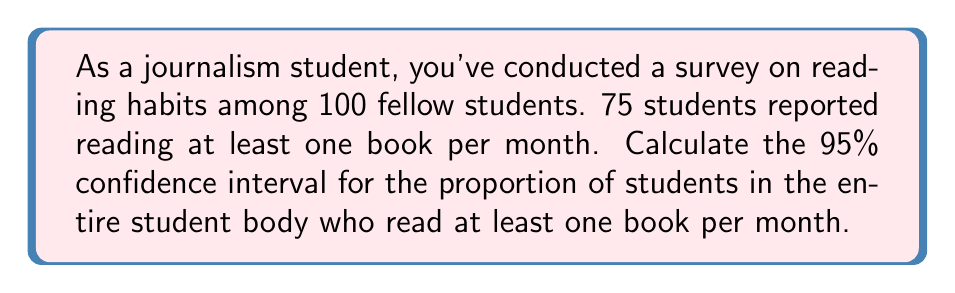Give your solution to this math problem. Let's approach this step-by-step:

1) We're dealing with a proportion, so we'll use the formula for the confidence interval of a proportion:

   $$p \pm z\sqrt{\frac{p(1-p)}{n}}$$

   Where:
   $p$ = sample proportion
   $z$ = z-score for desired confidence level
   $n$ = sample size

2) Calculate $p$:
   $p = \frac{75}{100} = 0.75$

3) For a 95% confidence interval, $z = 1.96$

4) $n = 100$

5) Plug these values into the formula:

   $$0.75 \pm 1.96\sqrt{\frac{0.75(1-0.75)}{100}}$$

6) Simplify:
   $$0.75 \pm 1.96\sqrt{\frac{0.75(0.25)}{100}}$$
   $$0.75 \pm 1.96\sqrt{0.001875}$$
   $$0.75 \pm 1.96(0.0433)$$
   $$0.75 \pm 0.0849$$

7) Calculate the interval:
   Lower bound: $0.75 - 0.0849 = 0.6651$
   Upper bound: $0.75 + 0.0849 = 0.8349$

Therefore, we can say with 95% confidence that the true proportion of students who read at least one book per month is between 0.6651 and 0.8349, or between 66.51% and 83.49%.
Answer: (0.6651, 0.8349) 